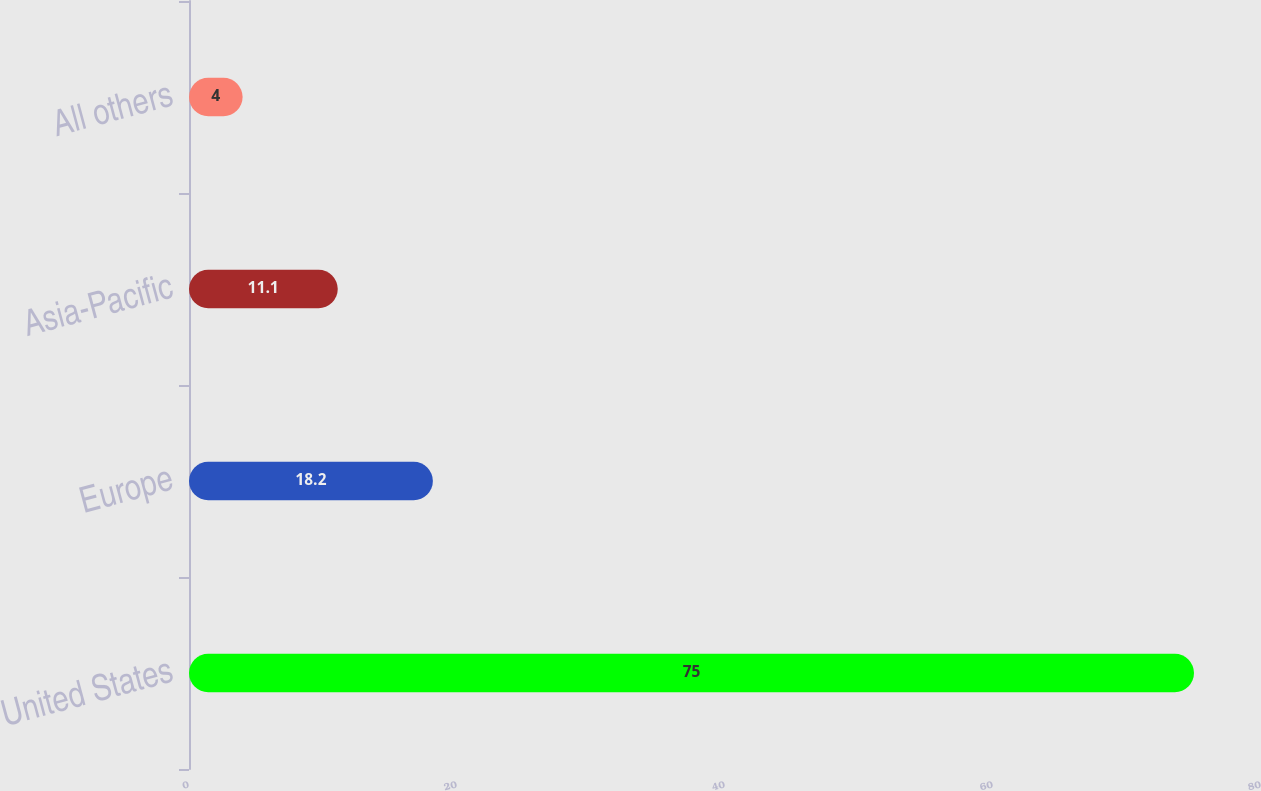Convert chart. <chart><loc_0><loc_0><loc_500><loc_500><bar_chart><fcel>United States<fcel>Europe<fcel>Asia-Pacific<fcel>All others<nl><fcel>75<fcel>18.2<fcel>11.1<fcel>4<nl></chart> 